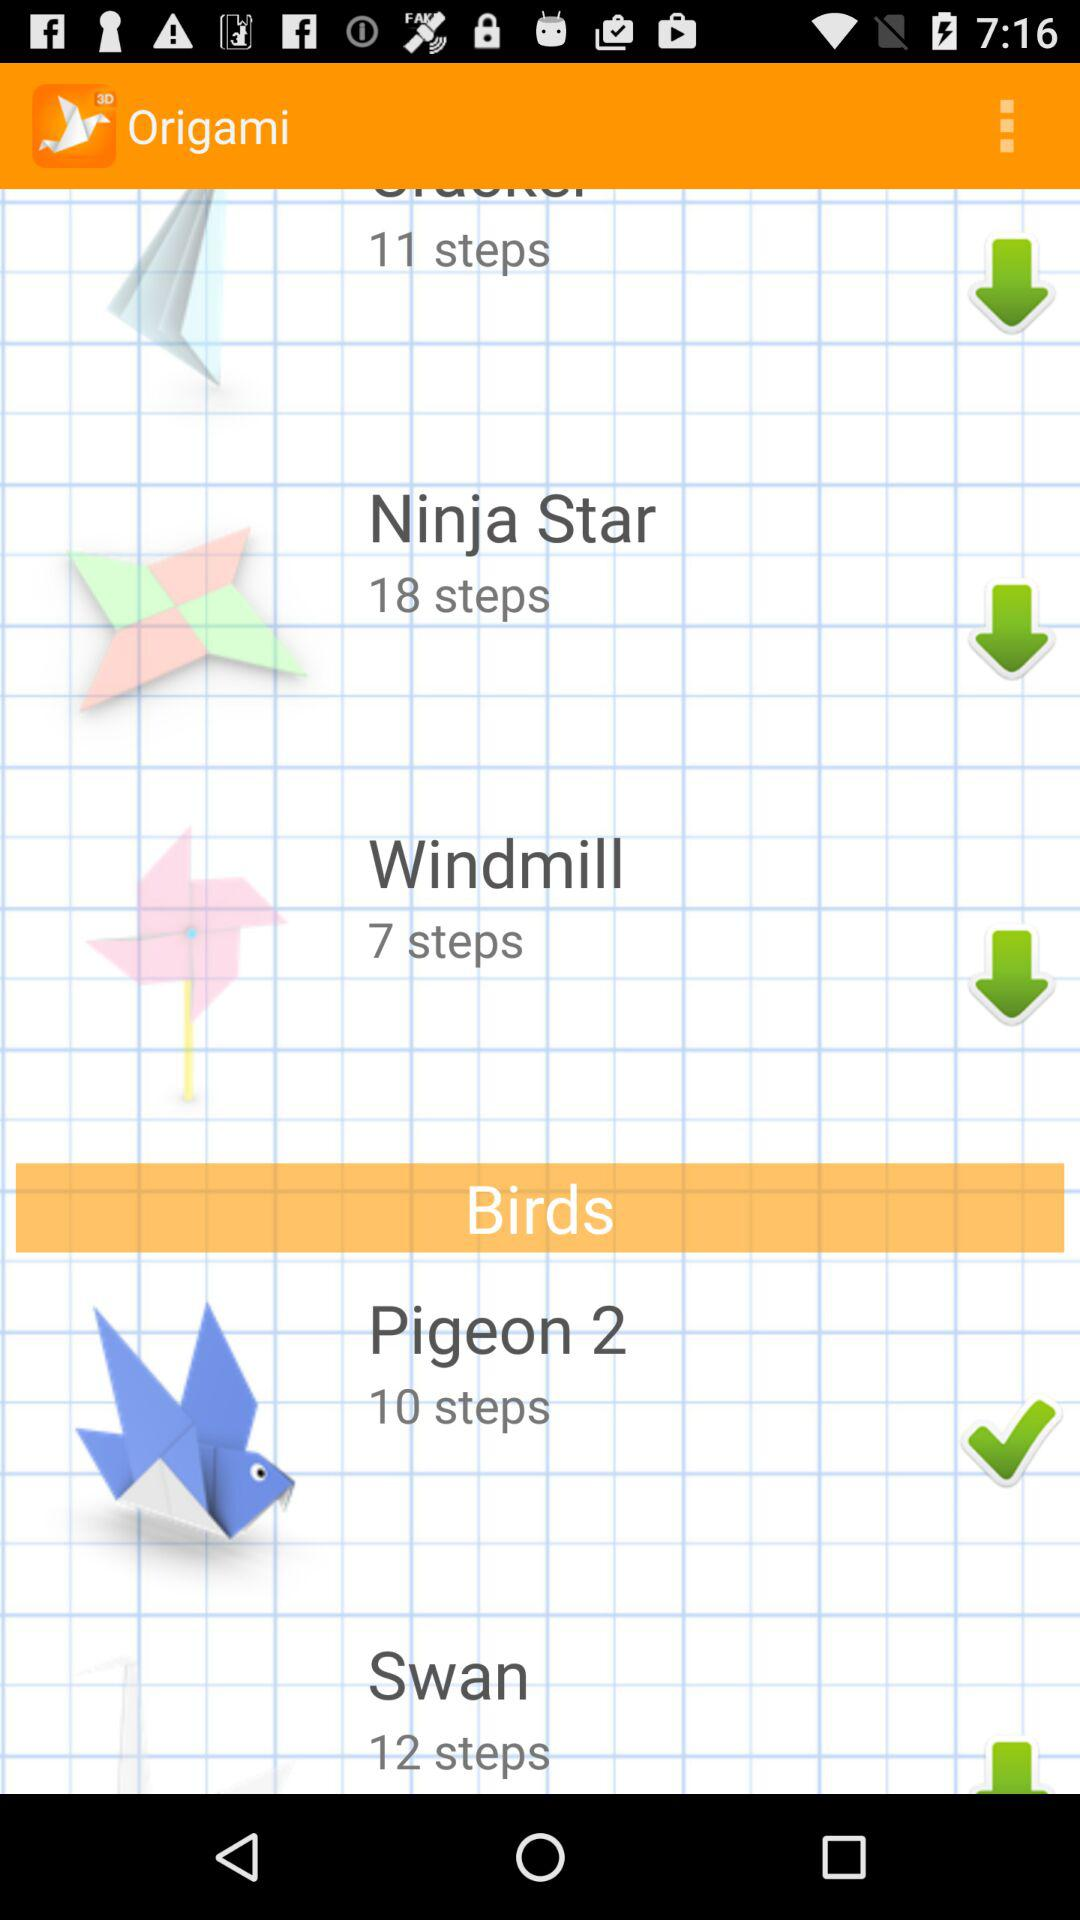What is the app name? The app name is "How to Make Origami". 